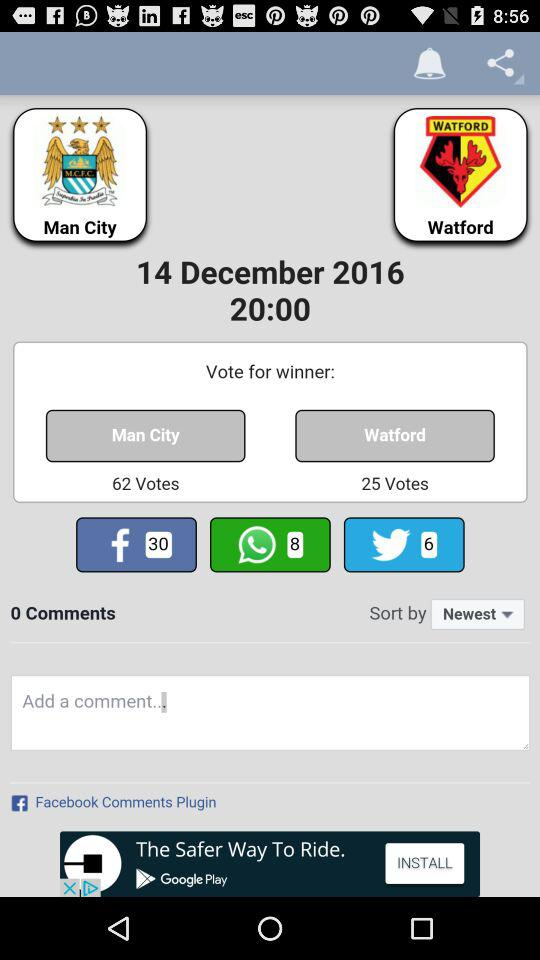What is the date and time? The date is December 14, 2016 and the time is 20:00. 